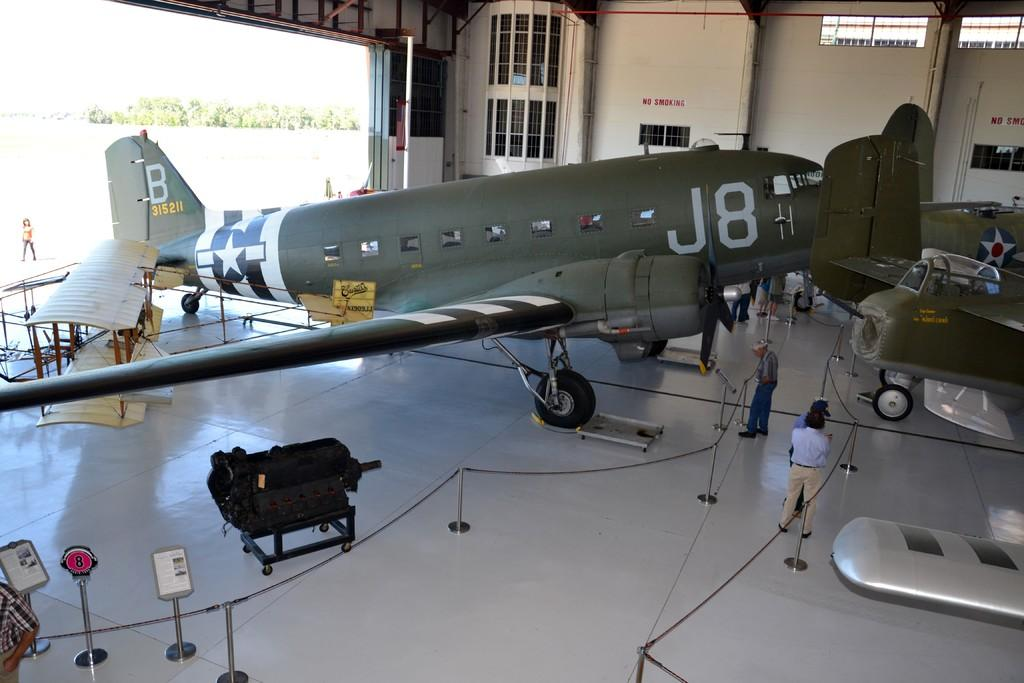What is the main subject of the image? The main subject of the image is airplanes. What can be seen on the ground in the image? There are people on the ground in the image. What structures are present in the image? There are stands and a wall in the image. What type of openings can be seen in the image? There are windows in the image. What is visible in the background of the image? There are trees and a person walking in the background of the image. What type of request is being made by the airplanes in the image? There is no text present in the image, so it is not possible to determine if any requests are being made. Additionally, airplanes do not make requests in the same way that people do. 